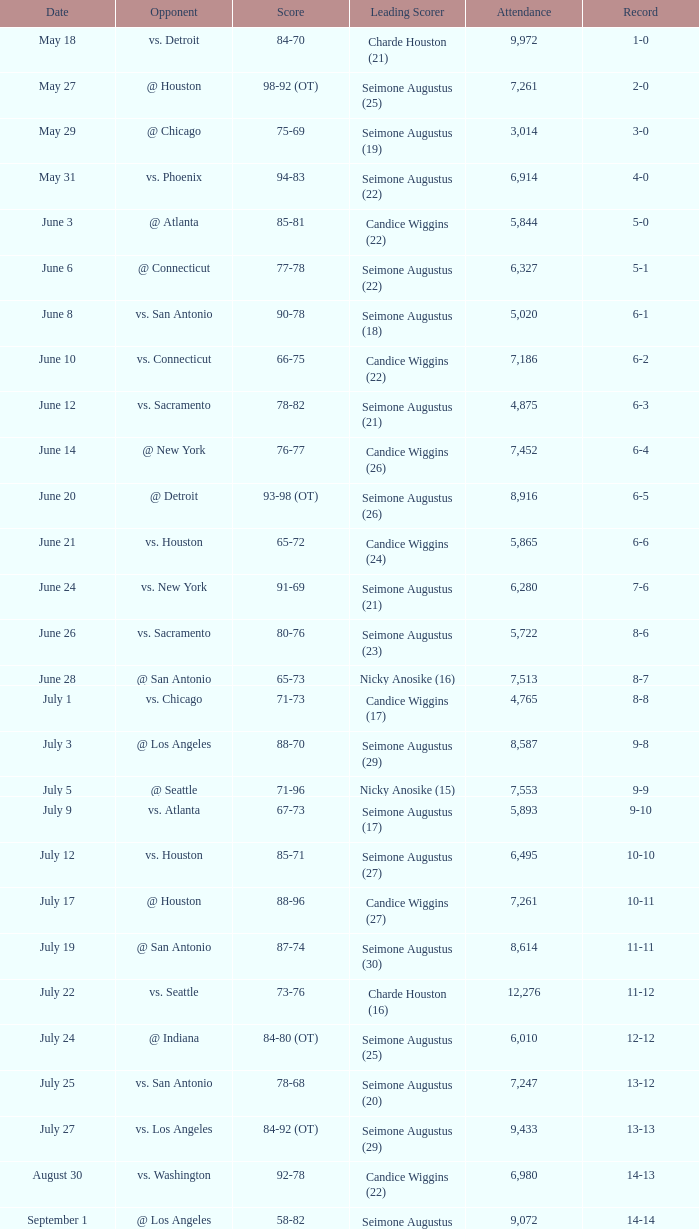What attendance corresponds to the date september 7? 7999.0. 